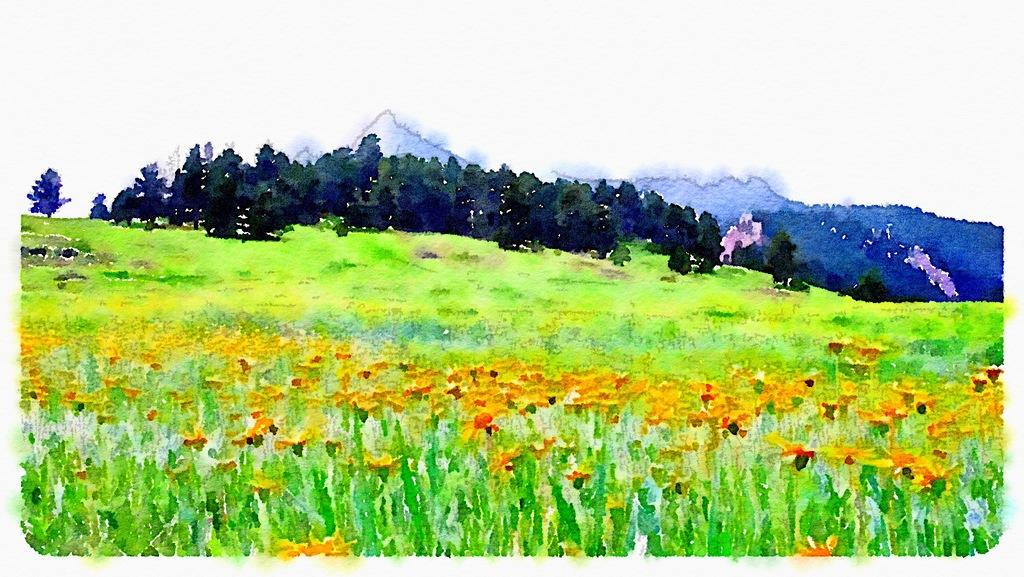What type of artwork is depicted in the image? The image is a painting. What is located at the bottom of the painting? There are plants at the bottom of the painting. What can be seen in the background of the painting? There are trees and mountains in the background of the painting. What type of porter is carrying a load of rain in the painting? There is no porter or rain present in the painting; it features plants, trees, and mountains. 